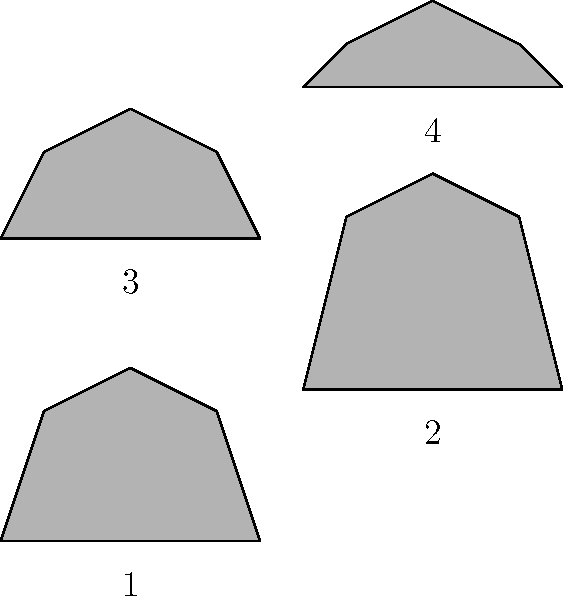Which silhouette represents the correct posture for playing the violin? To identify the correct posture for playing the violin, let's analyze each silhouette:

1. Silhouette 1 (top-left): This shows a slightly hunched posture with the head tilted downward. While this might feel natural for a beginner, it's not the ideal posture for playing the violin.

2. Silhouette 2 (top-right): This depicts an overly straight and rigid posture. While good posture is important, this extreme straightness can lead to tension and restrict movement.

3. Silhouette 3 (bottom-left): This silhouette shows a balanced, upright posture with a slight forward tilt of the upper body. The head is in a natural position, neither too high nor too low. This represents the correct posture for playing the violin.

4. Silhouette 4 (bottom-right): This silhouette shows an excessively relaxed or slumped posture, which would make it difficult to hold the violin properly and maintain good bow control.

The correct posture (Silhouette 3) allows for:
- Proper support of the violin between the shoulder and chin
- Natural alignment of the spine
- Freedom of movement in the arms and shoulders
- Good breath support
- Reduced risk of strain or injury

This posture facilitates better tone production, intonation, and overall playing technique.
Answer: Silhouette 3 (bottom-left) 